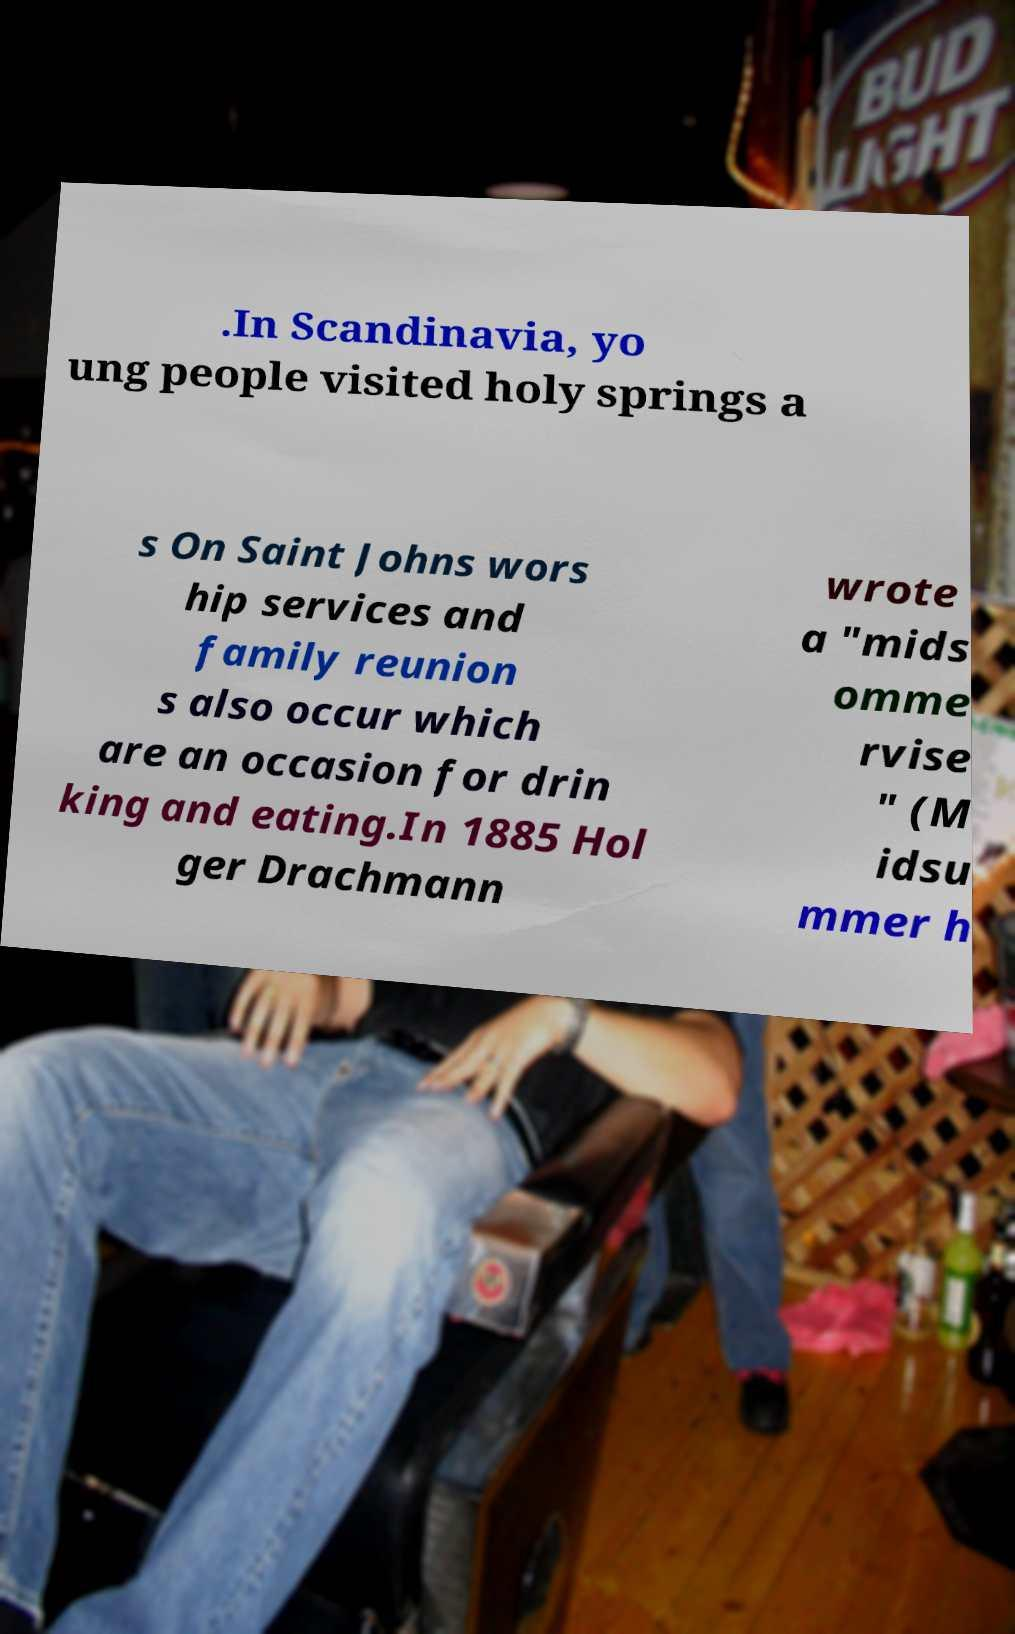What messages or text are displayed in this image? I need them in a readable, typed format. .In Scandinavia, yo ung people visited holy springs a s On Saint Johns wors hip services and family reunion s also occur which are an occasion for drin king and eating.In 1885 Hol ger Drachmann wrote a "mids omme rvise " (M idsu mmer h 